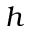Convert formula to latex. <formula><loc_0><loc_0><loc_500><loc_500>h</formula> 